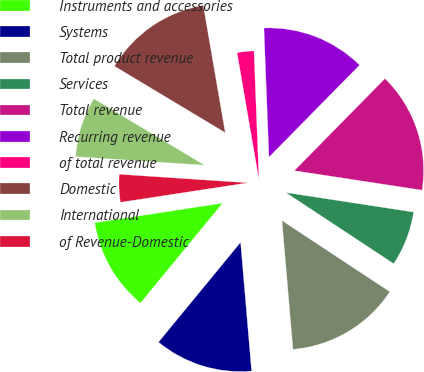Convert chart to OTSL. <chart><loc_0><loc_0><loc_500><loc_500><pie_chart><fcel>Instruments and accessories<fcel>Systems<fcel>Total product revenue<fcel>Services<fcel>Total revenue<fcel>Recurring revenue<fcel>of total revenue<fcel>Domestic<fcel>International<fcel>of Revenue-Domestic<nl><fcel>11.63%<fcel>12.31%<fcel>14.36%<fcel>6.87%<fcel>15.04%<fcel>12.99%<fcel>2.1%<fcel>13.68%<fcel>7.55%<fcel>3.47%<nl></chart> 